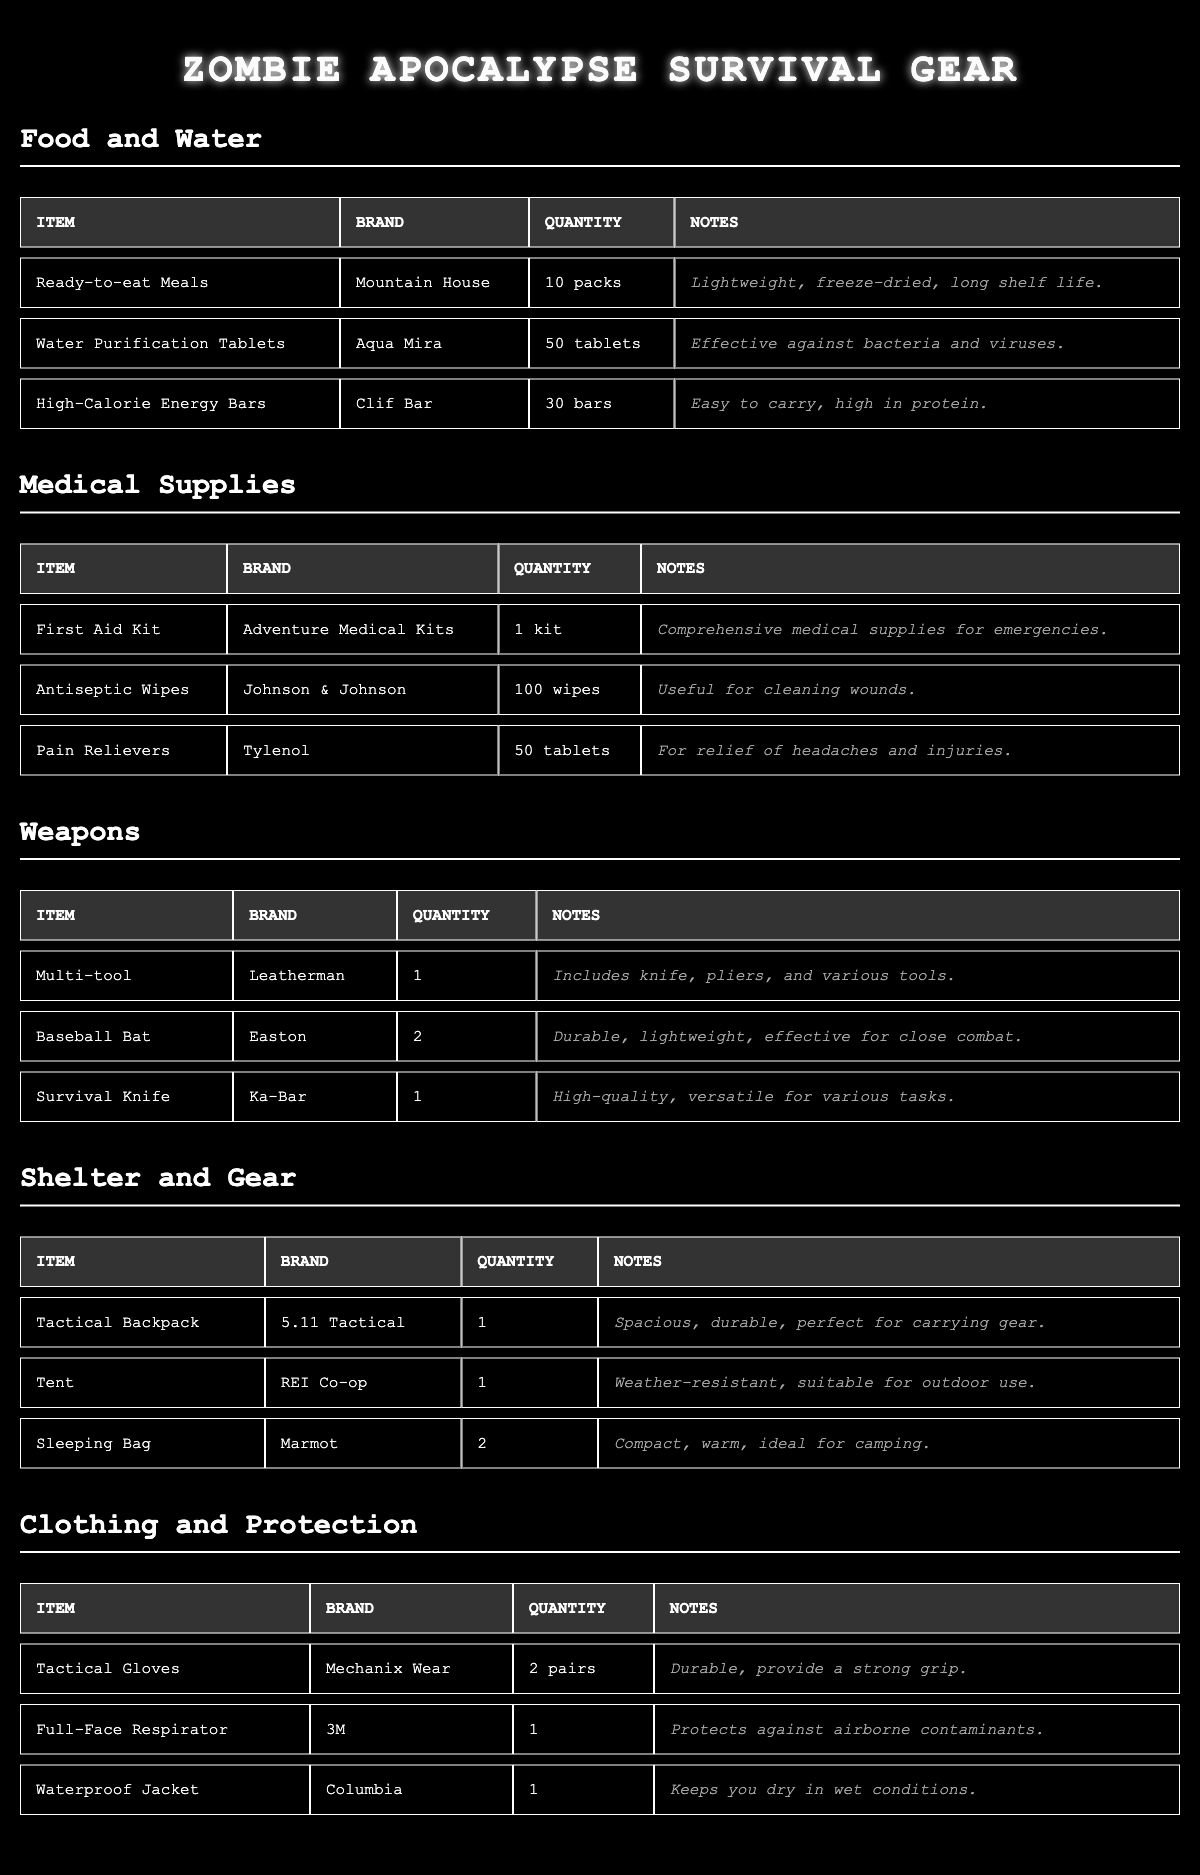What is the total quantity of High-Calorie Energy Bars? The table shows there are 30 High-Calorie Energy Bars listed under the Food and Water category.
Answer: 30 How many different brands of medical supplies are listed? There are 3 different brands of medical supplies: Adventure Medical Kits, Johnson & Johnson, and Tylenol.
Answer: 3 What item has the highest quantity in the table? The item with the highest quantity is Antiseptic Wipes with 100 wipes under the Medical Supplies category.
Answer: Antiseptic Wipes Are there more items in the Weapons category than in the Clothing and Protection category? The Weapons category has 3 items while the Clothing and Protection category also has 3 items, making them equal.
Answer: No What is the total number of Sleeping Bags and Tactical Gloves combined? The table lists 2 Sleeping Bags and 2 pairs of Tactical Gloves, so total is 2 + 2 = 4.
Answer: 4 Is there any item in the Shelter and Gear category that is suitable for outdoor use? Yes, the Tent listed under Shelter and Gear is specified as weather-resistant and suitable for outdoor use.
Answer: Yes How many packs of Ready-to-eat Meals are there compared to the total number of tablets of Water Purification? There are 10 packs of Ready-to-eat Meals and 50 Water Purification Tablets, with a total comparison of 10 vs. 50. The comparison of packs to tablets shows that tablets are more.
Answer: 10 vs. 50 (tablets are more) Which item contains tools in addition to a knife? The Multi-tool from Leatherman includes a knife along with pliers and various other tools.
Answer: Multi-tool How many more Baseball Bats are there than Survival Knives? The table shows 2 Baseball Bats and 1 Survival Knife, resulting in a difference of 1 (2 - 1 = 1).
Answer: 1 Is the Waterproof Jacket suitable for staying dry in wet conditions? Yes, the Waterproof Jacket from Columbia is noted to keep you dry in wet conditions, confirming its suitability.
Answer: Yes 